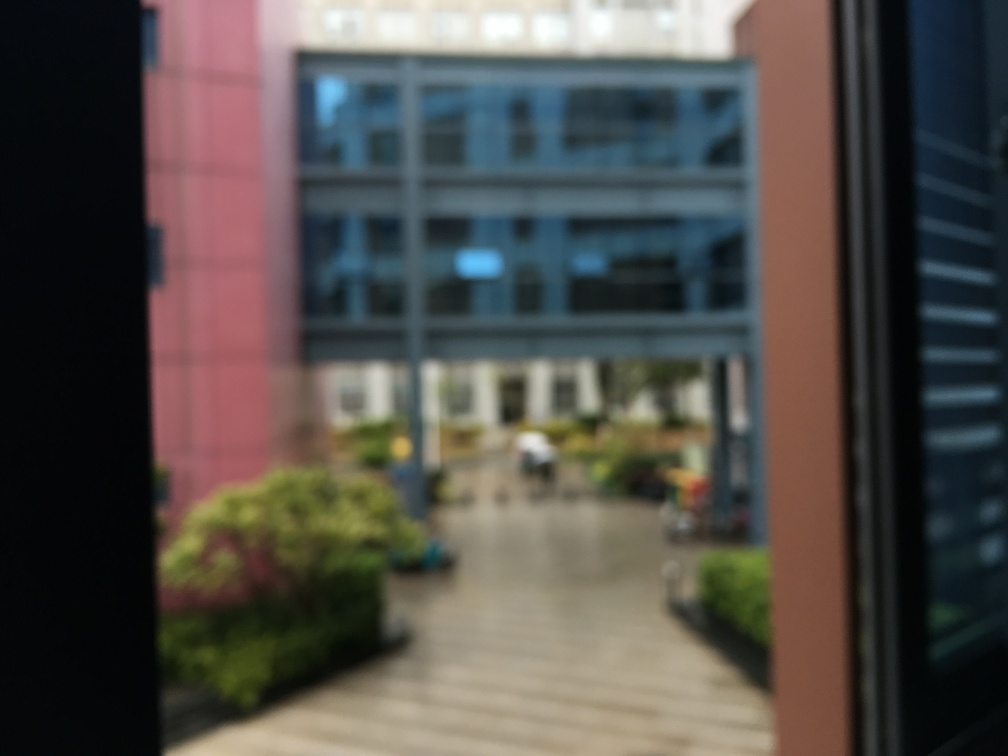Describe the environment surrounding the building? From what can be seen, the building is surrounded by an outdoor area with greenery, including what appears to be a landscaped garden. There's a walkway leading towards it, suggesting a welcoming environment, possibly a courtyard or plaza for public use. 